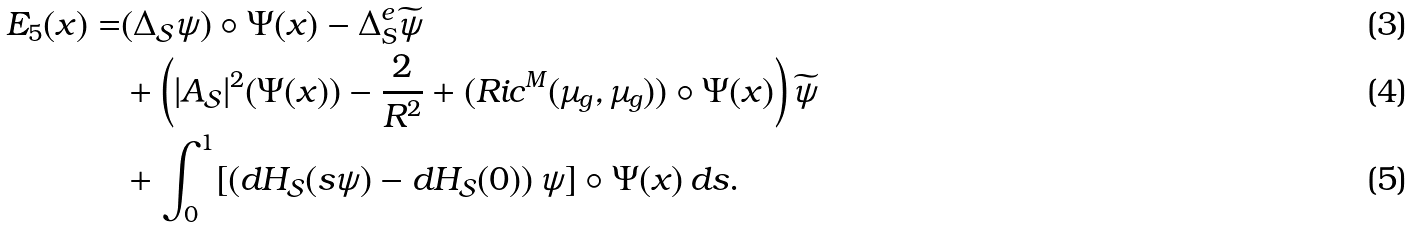<formula> <loc_0><loc_0><loc_500><loc_500>E _ { 5 } ( x ) = & ( \Delta _ { \mathcal { S } } \psi ) \circ \Psi ( x ) - \Delta _ { S } ^ { e } \widetilde { \psi } \\ & + \left ( | A _ { \mathcal { S } } | ^ { 2 } ( \Psi ( x ) ) - \frac { 2 } { R ^ { 2 } } + ( R i c ^ { M } ( \mu _ { g } , \mu _ { g } ) ) \circ \Psi ( x ) \right ) \widetilde { \psi } \\ & + \int _ { 0 } ^ { 1 } [ \left ( d H _ { \mathcal { S } } ( s \psi ) - d H _ { \mathcal { S } } ( 0 ) \right ) \psi ] \circ \Psi ( x ) \, d s .</formula> 